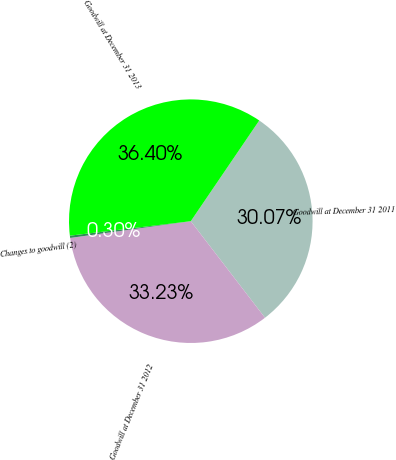Convert chart to OTSL. <chart><loc_0><loc_0><loc_500><loc_500><pie_chart><fcel>Goodwill at December 31 2011<fcel>Goodwill at December 31 2012<fcel>Changes to goodwill (2)<fcel>Goodwill at December 31 2013<nl><fcel>30.07%<fcel>33.23%<fcel>0.3%<fcel>36.4%<nl></chart> 